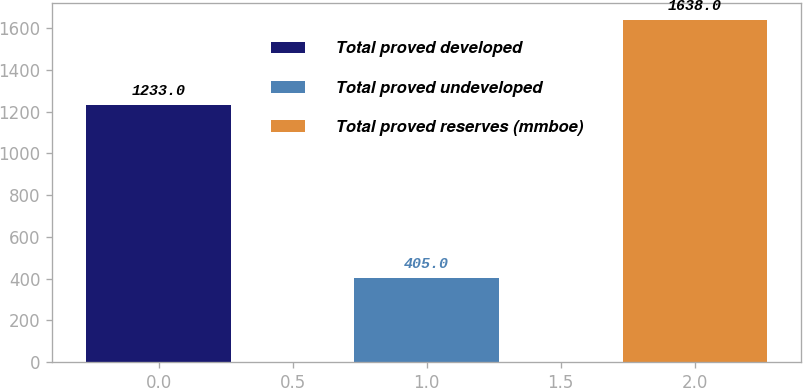<chart> <loc_0><loc_0><loc_500><loc_500><bar_chart><fcel>Total proved developed<fcel>Total proved undeveloped<fcel>Total proved reserves (mmboe)<nl><fcel>1233<fcel>405<fcel>1638<nl></chart> 